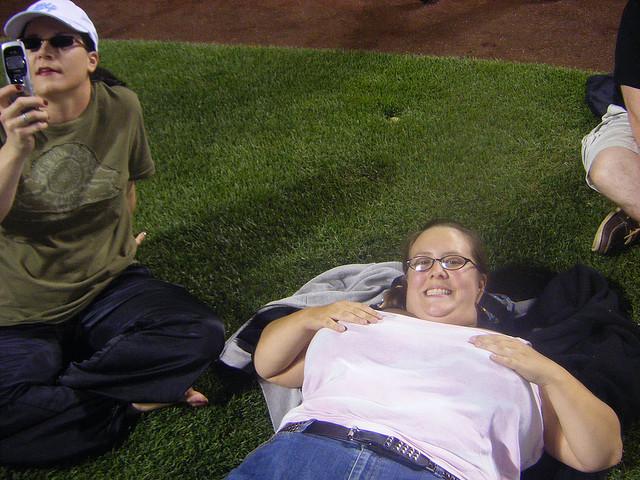Does this woman laying on the ground have unaided 20/20 vision?
Concise answer only. No. What's the woman that's sitting holding?
Give a very brief answer. Phone. Is the woman laying down touching her breast?
Short answer required. Yes. 